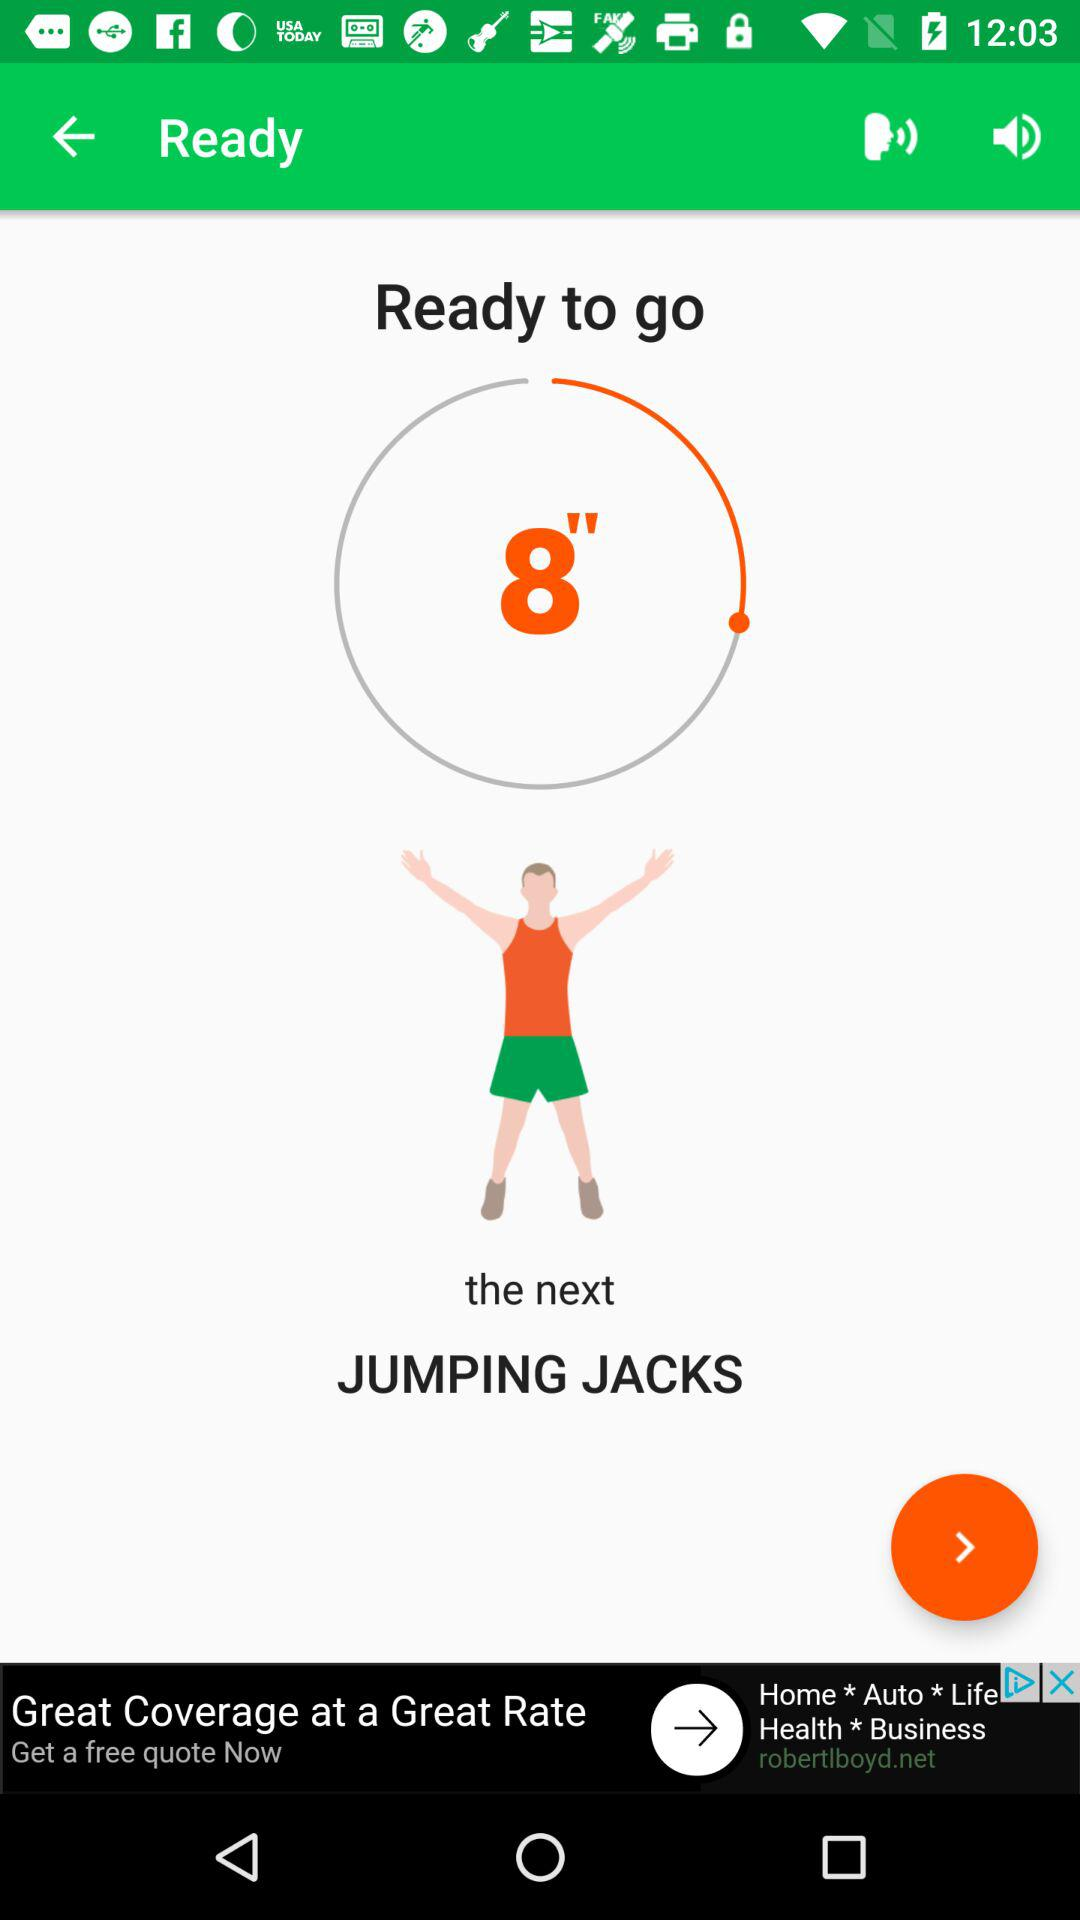How much time is shown on the timer for the next activity? The timer on the app is indicating that there are 8 seconds left before the next activity, which is jumping jacks, should start. 